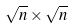Convert formula to latex. <formula><loc_0><loc_0><loc_500><loc_500>\sqrt { n } \times \sqrt { n }</formula> 